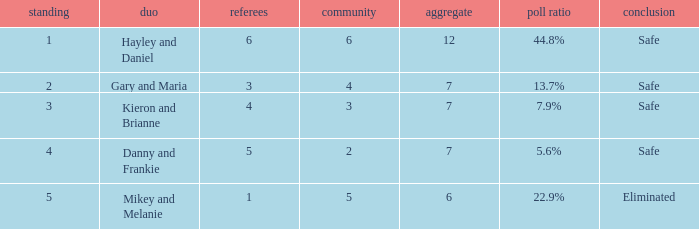What was the maximum rank for the vote percentage of 5.6% 4.0. 